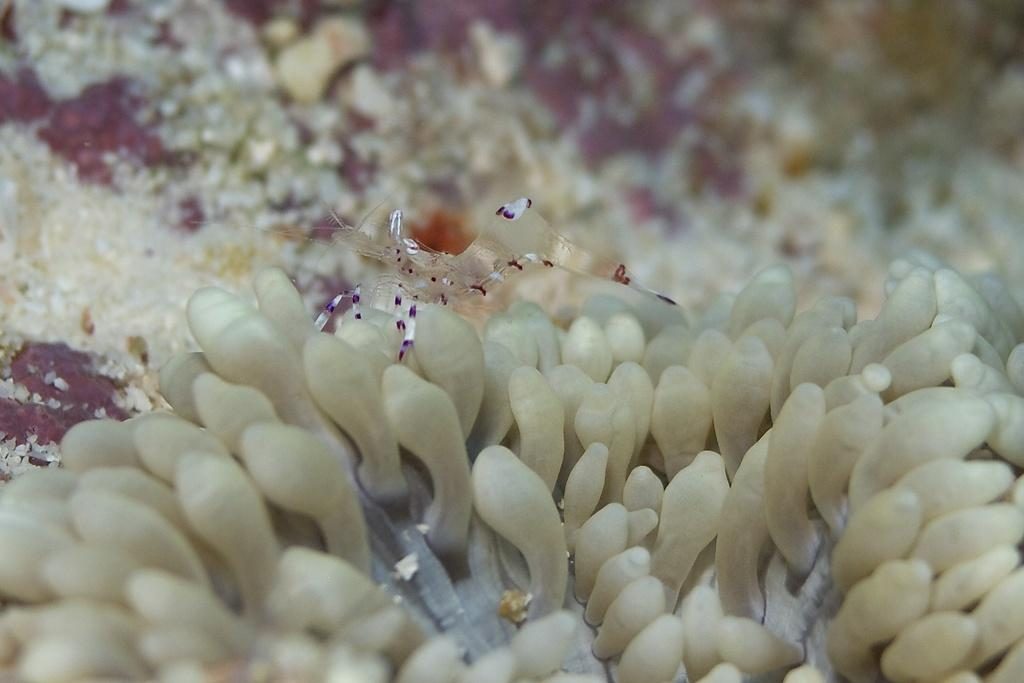What type of creature can be seen in the image? There is an insect in the image. Where is the insect located? The insect is on a plant. What is the color of the plant? The plant is white in color. What type of pie is being served on the beam in the image? There is no beam or pie present in the image; it features an insect on a white plant. 